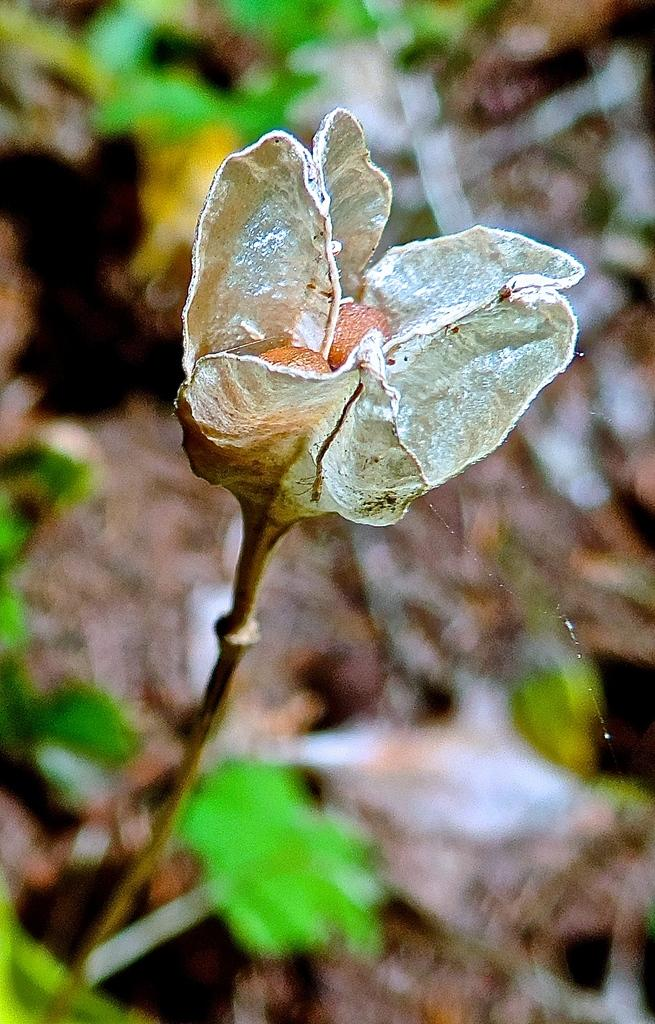What is the main subject in the middle of the image? There is a flower in the middle of the image. What colors can be seen in the background of the image? There is green color and brown color in the background of the image. How many goldfish are swimming in the flower in the image? There are no goldfish present in the image, as it features a flower and background colors. 